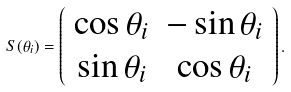Convert formula to latex. <formula><loc_0><loc_0><loc_500><loc_500>S ( \theta _ { i } ) = \left ( \begin{array} { c c } \cos \theta _ { i } & - \sin \theta _ { i } \\ \sin \theta _ { i } & \cos \theta _ { i } \\ \end{array} \right ) .</formula> 